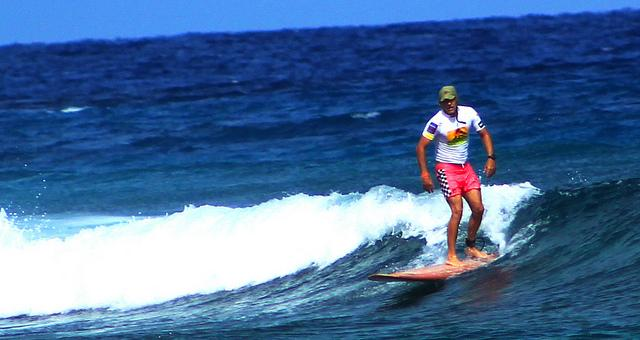What might he have applied before going out there? sunscreen 